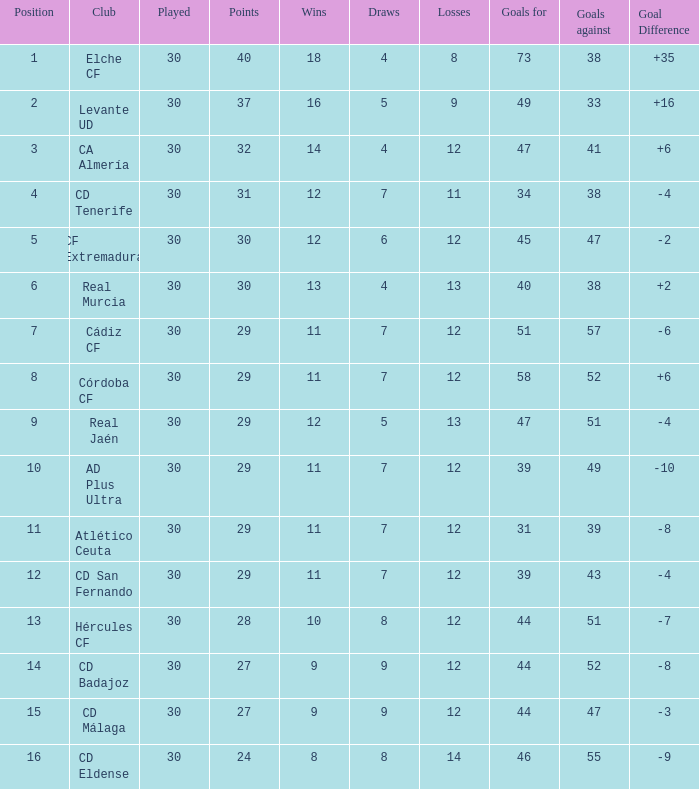What is the total number of losses with less than 73 goals for, less than 11 wins, more than 24 points, and a position greater than 15? 0.0. 